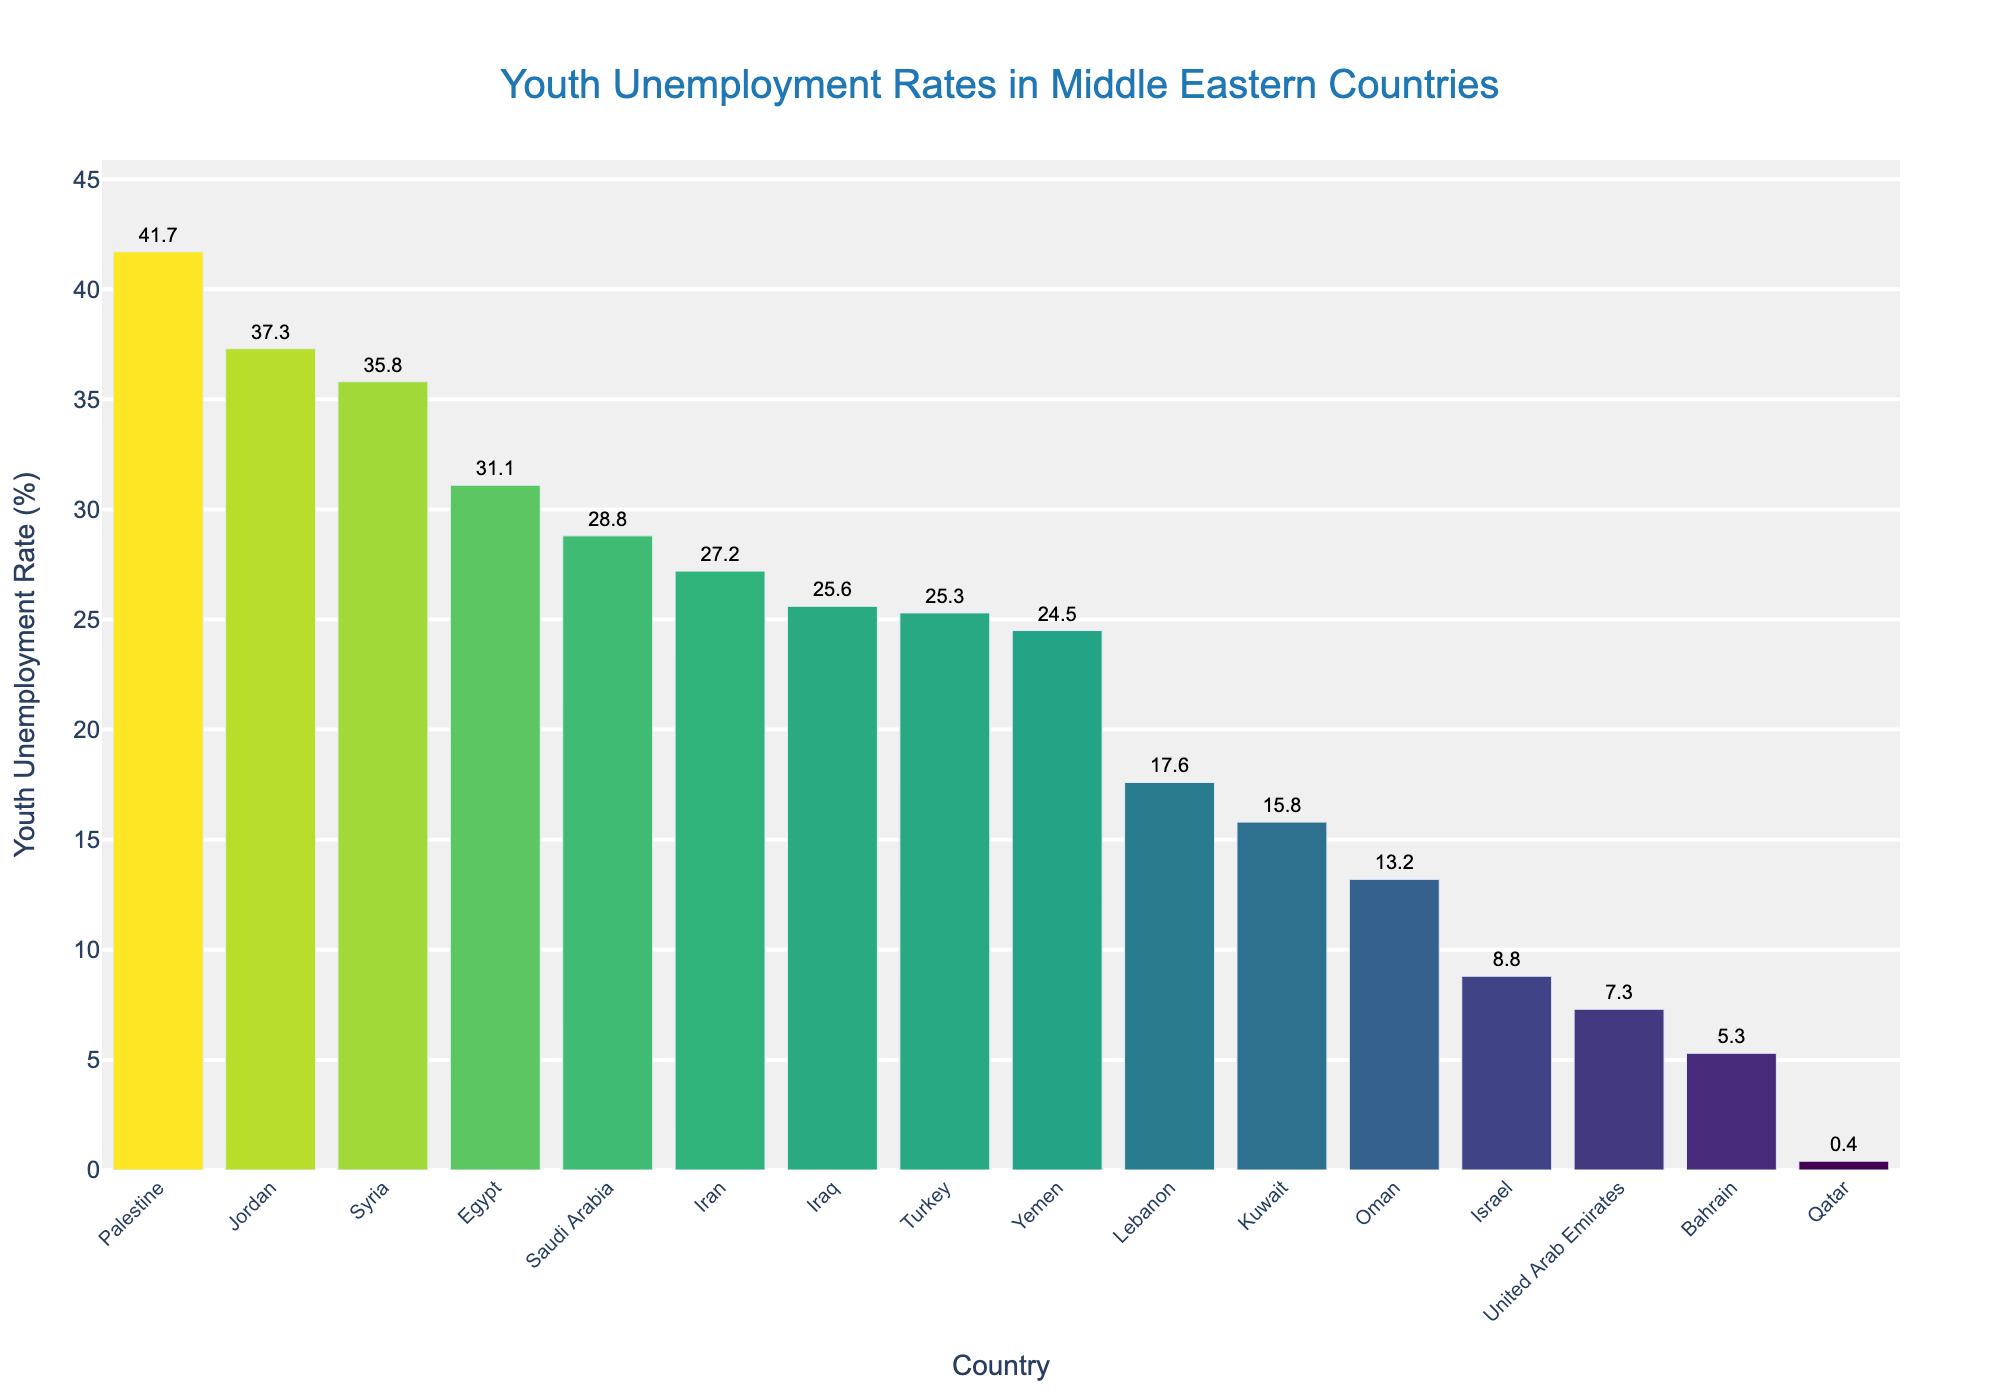What is the country with the highest youth unemployment rate? The highest bar in the plot represents the highest youth unemployment rate. By observing the chart, we see that Palestine has the tallest bar.
Answer: Palestine Which two countries have youth unemployment rates closest to 25%? By looking closely at the lengths of bars around the 25% mark, we see that Turkey and Iraq have youth unemployment rates closest to 25%.
Answer: Turkey and Iraq What is the difference in youth unemployment rates between Qatar and Saudi Arabia? Qatar's youth unemployment rate is 0.4% and Saudi Arabia's is 28.8%. The difference is 28.8 - 0.4 = 28.4.
Answer: 28.4 How many countries have youth unemployment rates below 10%? By counting the bars that do not reach the 10% line, we find that there are 4 countries: United Arab Emirates, Israel, Bahrain, and Qatar.
Answer: 4 What is the average youth unemployment rate of the three countries with the lowest rates? The three countries with the lowest rates are Qatar (0.4%), Bahrain (5.3%), and United Arab Emirates (7.3%). The average is calculated by (0.4 + 5.3 + 7.3) / 3 = 13/3 ≈ 4.33.
Answer: Approximately 4.3 Which country has a higher youth unemployment rate: Lebanon or Kuwait? By comparing the heights of the bars for Lebanon and Kuwait, Lebanon's bar is taller, indicating a higher youth unemployment rate. Lebanon's rate is 17.6% while Kuwait's is 15.8%.
Answer: Lebanon What is the combined youth unemployment rate for Syria, Yemen, and Jordan? The youth unemployment rates for Syria (35.8%), Yemen (24.5%), and Jordan (37.3%) added together are 35.8 + 24.5 + 37.3 = 97.6.
Answer: 97.6 Which country has a similar youth unemployment rate to Iran? By comparing the bar heights around Iran's rate (27.2%), we find that Saudi Arabia has a similar unemployment rate of 28.8%.
Answer: Saudi Arabia Is the youth unemployment rate in Israel higher or lower than in Oman? By comparing the heights of the bars for Israel and Oman, Israel's bar is higher. Israel's rate is 8.8% while Oman's is 13.2%, so Israel's rate is lower.
Answer: Lower What is the median youth unemployment rate among the countries listed? To find the median, the youth unemployment rates need to be ordered and the middle value selected. Ordering the rates, we find the middle values are Egypt (31.1%), Palestine (41.7%), Syria (35.8%), Jordan (37.3%), and Turkey (25.3%). With an even number of countries, the average of the middle two (Kuwait (15.8%) and Lebanon (17.6%)) is (15.8 + 17.6) / 2 = 16.7.
Answer: 16.7 